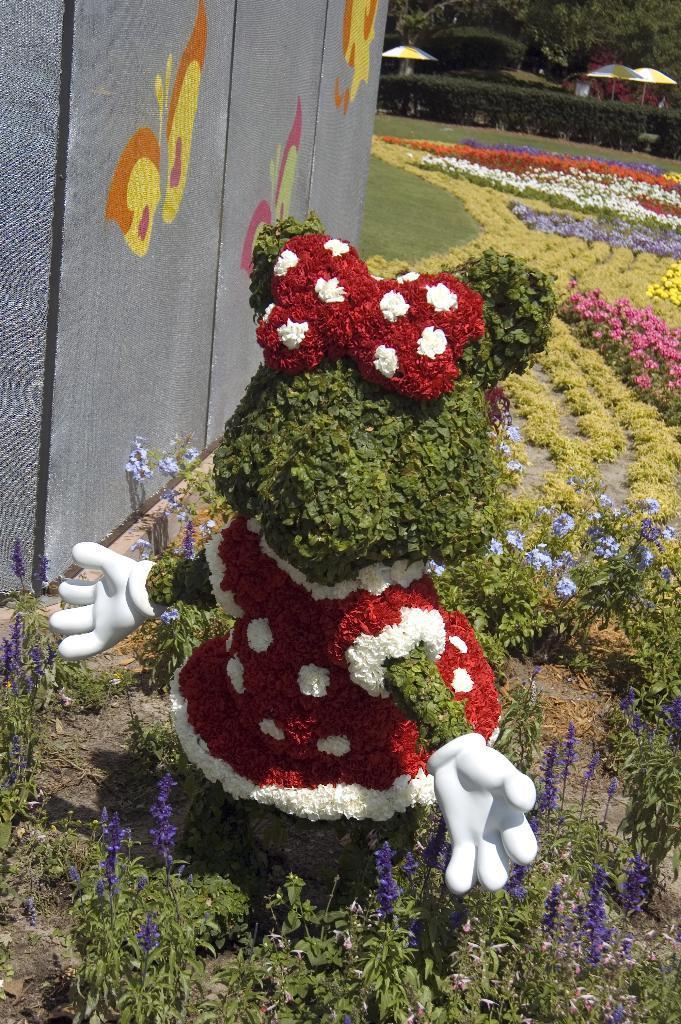In one or two sentences, can you explain what this image depicts? In this image there are few plants having flowers. Middle of the image there is a plant which is carved in the shape of a toy having few flowers and leaves on it. Left side there is a wall having some painting on it. Right side there are few umbrellas on the grassland having few plants and trees. 